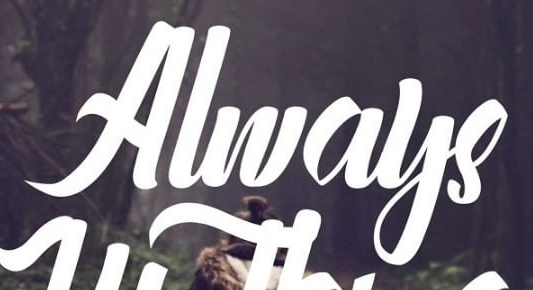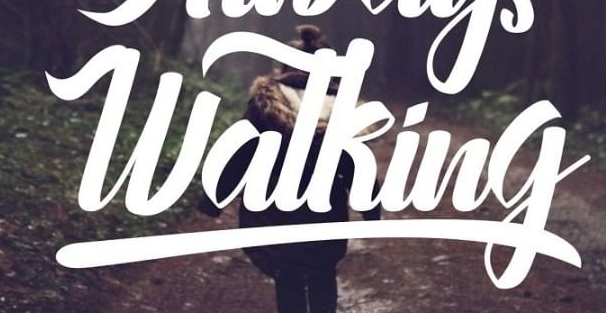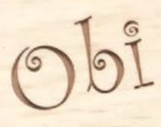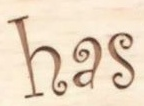What text is displayed in these images sequentially, separated by a semicolon? Always; Watking; Obi; has 